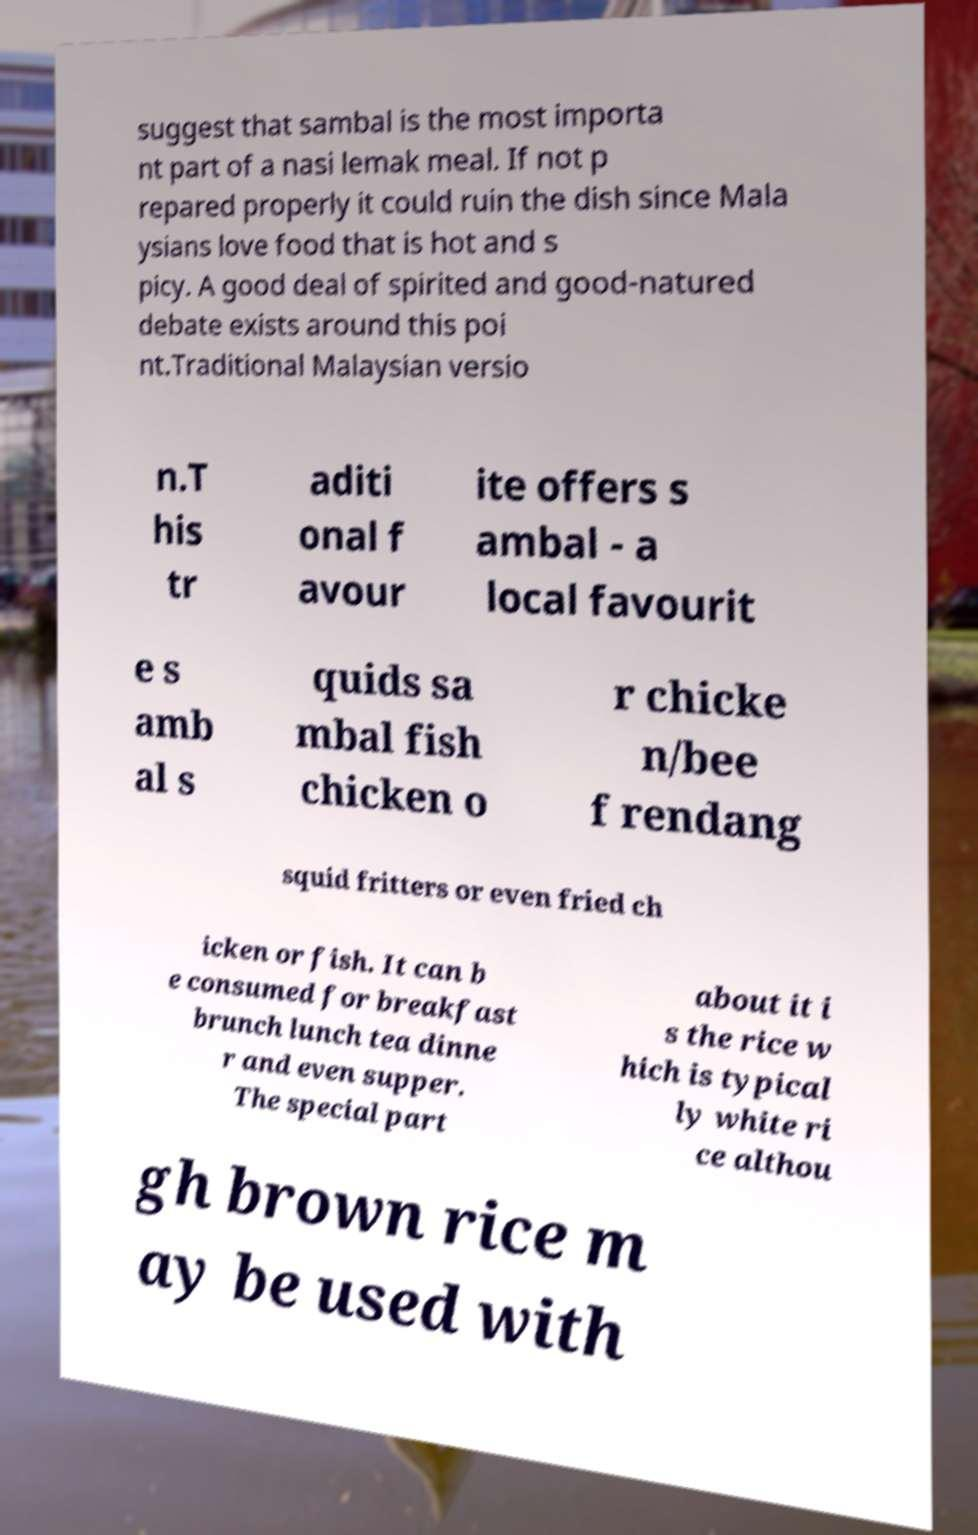Could you assist in decoding the text presented in this image and type it out clearly? suggest that sambal is the most importa nt part of a nasi lemak meal. If not p repared properly it could ruin the dish since Mala ysians love food that is hot and s picy. A good deal of spirited and good-natured debate exists around this poi nt.Traditional Malaysian versio n.T his tr aditi onal f avour ite offers s ambal - a local favourit e s amb al s quids sa mbal fish chicken o r chicke n/bee f rendang squid fritters or even fried ch icken or fish. It can b e consumed for breakfast brunch lunch tea dinne r and even supper. The special part about it i s the rice w hich is typical ly white ri ce althou gh brown rice m ay be used with 